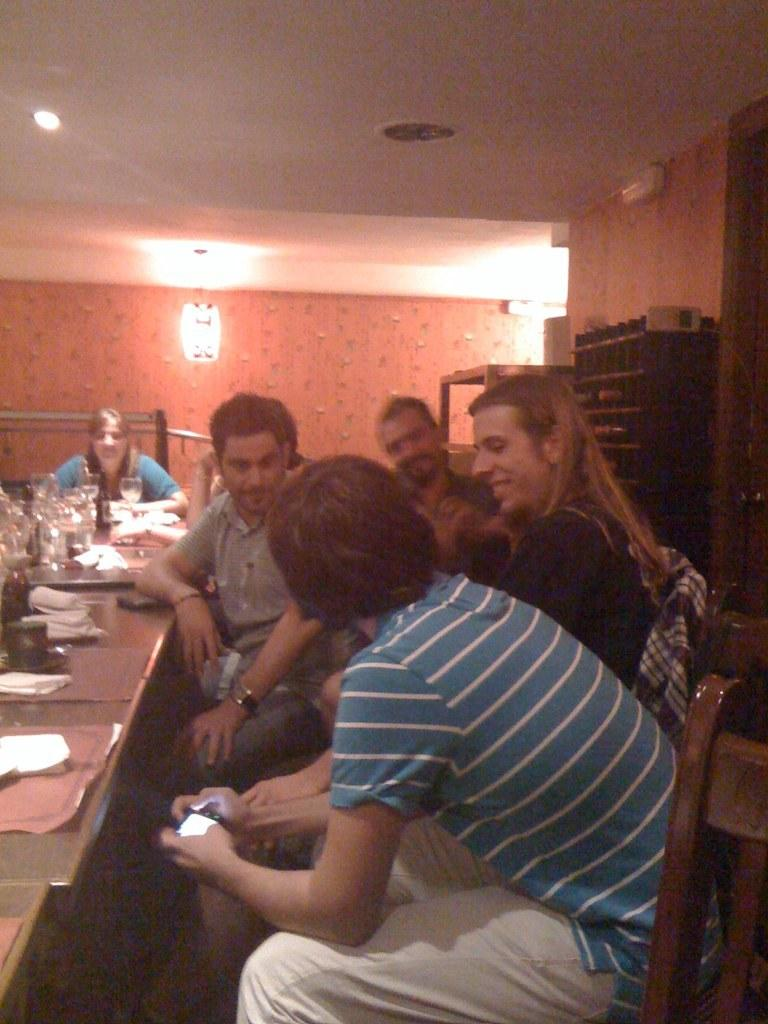What are the people in the image doing? The persons in the image are sitting on chairs. What is on the table in the image? There are glasses, paper, and other things on the table. Can you describe the table in the image? The table is in the image, and it has glasses, paper, and other things on it. What is visible in the background of the image? There is a wall in the background of the image. What is the source of light in the image? There is a light visible at the top of the image. What time is it in the image? The time cannot be determined from the image, as there is no clock or any indication of the time of day. What type of loaf is being observed on the table? There is no loaf present on the table in the image. 